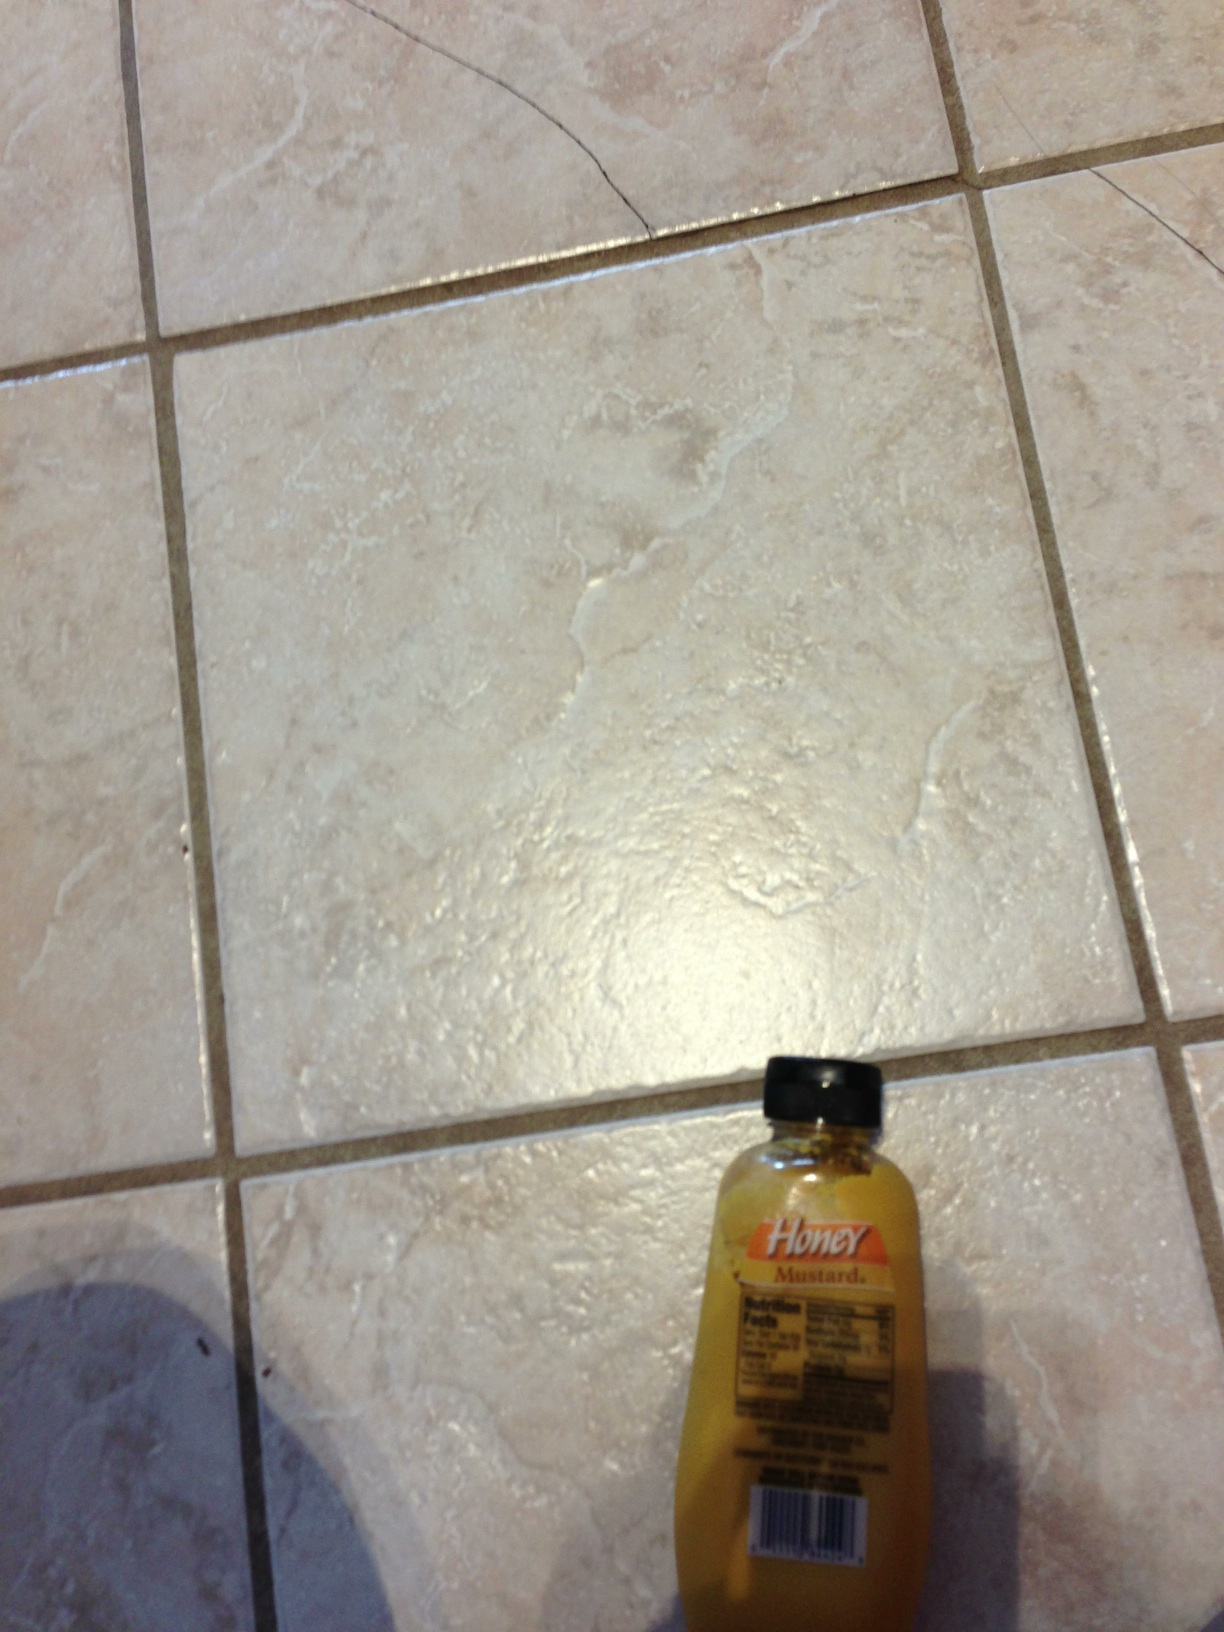What different types of dishes can be enhanced with honey mustard? Honey mustard can enhance a wide range of dishes, including salads, sandwiches, grilled meats, roasted vegetables, and even as a unique pizza topping. It adds a sweet and tangy flavor that pairs well with both savory and sweet elements. 